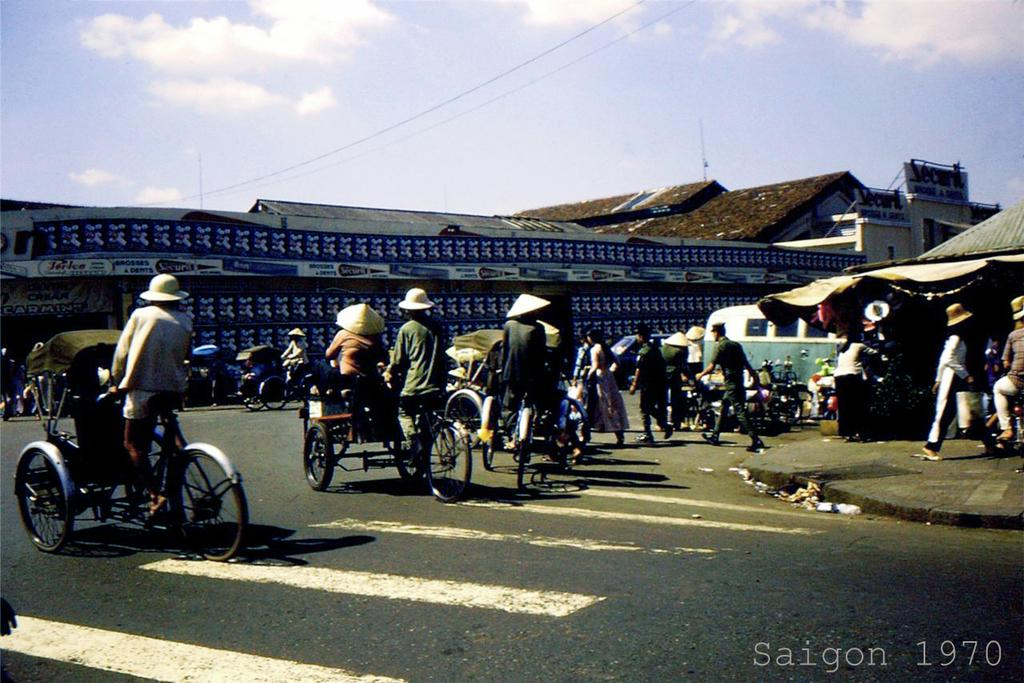What are the people in the image doing? The people in the image are riding a rickshaw. Where is the rickshaw located? The rickshaw is on a road. What can be seen in the background of the image? There is a house and the sky visible in the background of the image. How many boys are singing in the image? There are no boys singing in the image. The image shows people riding a rickshaw on a road, with a house and the sky visible in the background. 